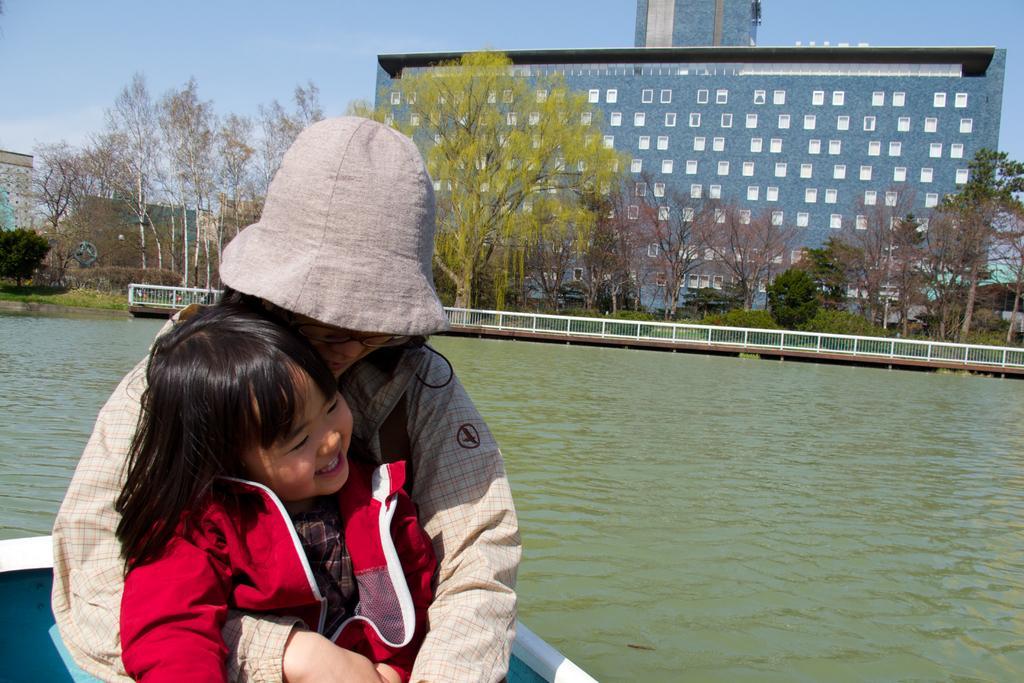Please provide a concise description of this image. In this picture we can see there are two people on the boat and behind the people there is water, fence, trees and buildings. Behind the buildings there is a sky. 